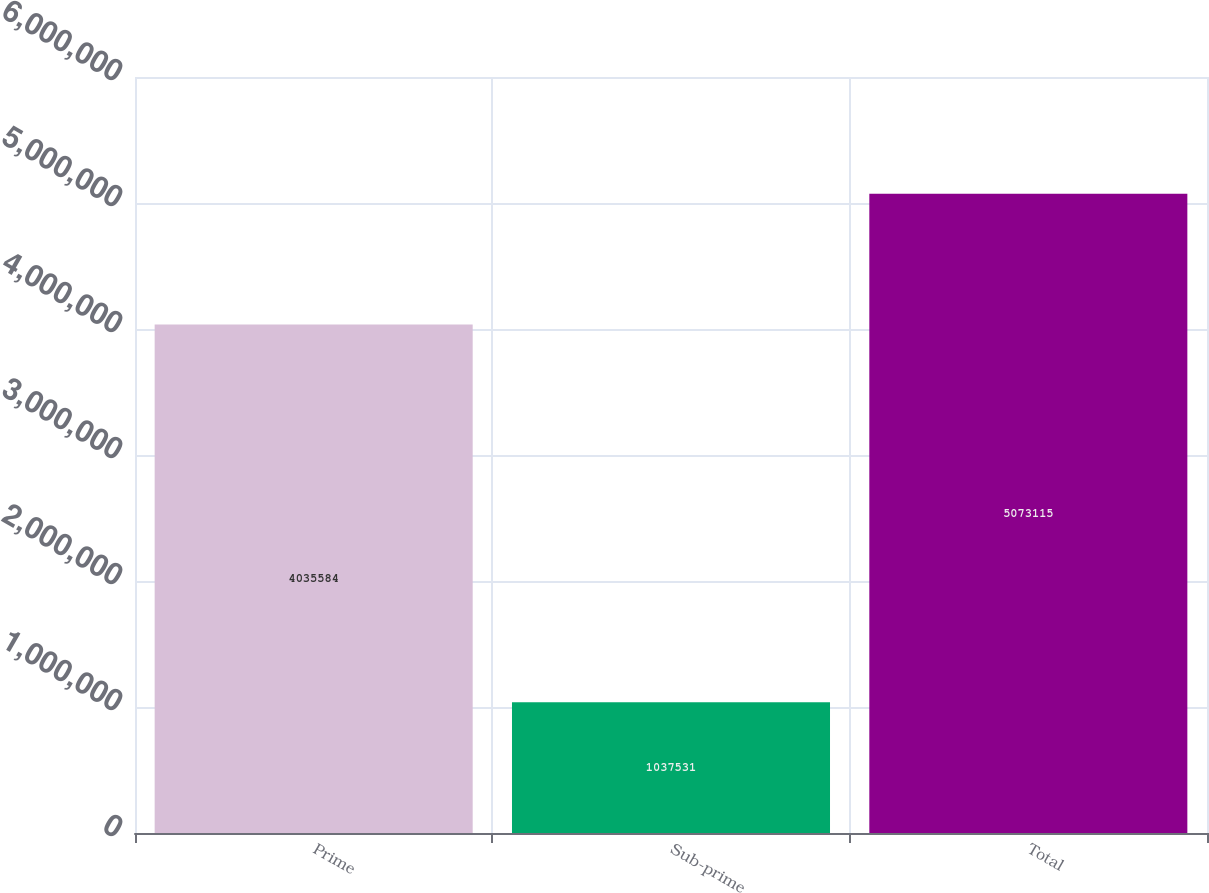<chart> <loc_0><loc_0><loc_500><loc_500><bar_chart><fcel>Prime<fcel>Sub-prime<fcel>Total<nl><fcel>4.03558e+06<fcel>1.03753e+06<fcel>5.07312e+06<nl></chart> 